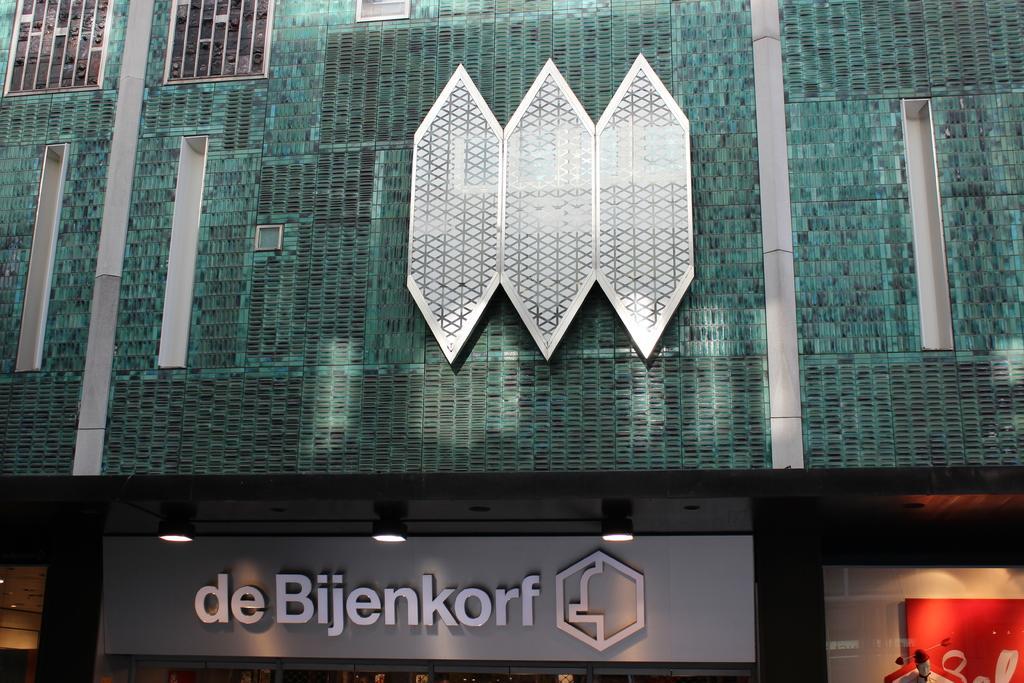Please provide a concise description of this image. In this picture we can see a building, boards, mannequin and lights. 